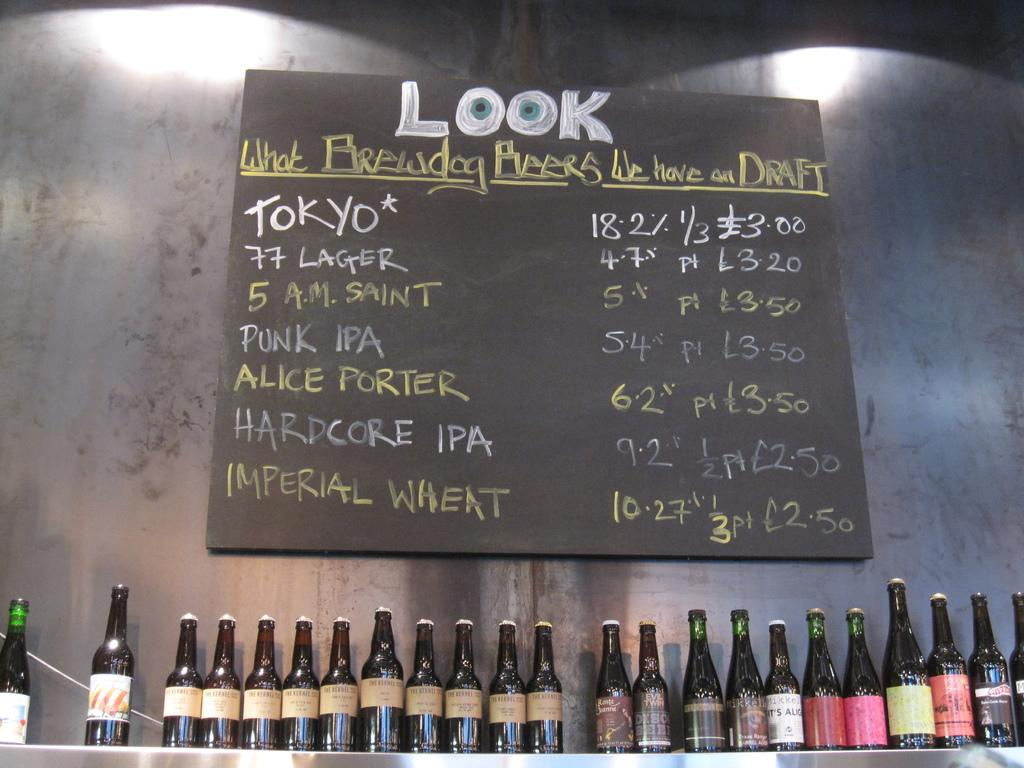<image>
Render a clear and concise summary of the photo. Beer bottles in a line below a chalk board menu that says "Look What Brewdog Beers We Have on Draft". 